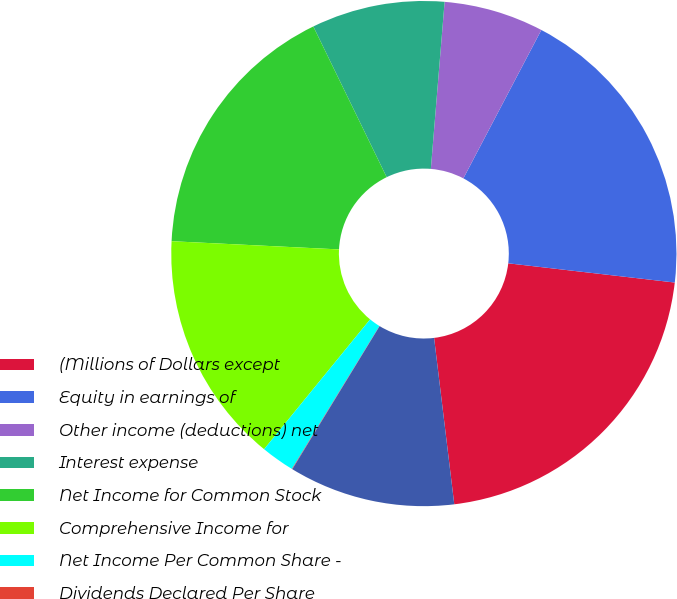Convert chart to OTSL. <chart><loc_0><loc_0><loc_500><loc_500><pie_chart><fcel>(Millions of Dollars except<fcel>Equity in earnings of<fcel>Other income (deductions) net<fcel>Interest expense<fcel>Net Income for Common Stock<fcel>Comprehensive Income for<fcel>Net Income Per Common Share -<fcel>Dividends Declared Per Share<fcel>Average Number Of Shares<nl><fcel>21.25%<fcel>19.13%<fcel>6.39%<fcel>8.52%<fcel>17.01%<fcel>14.88%<fcel>2.15%<fcel>0.03%<fcel>10.64%<nl></chart> 